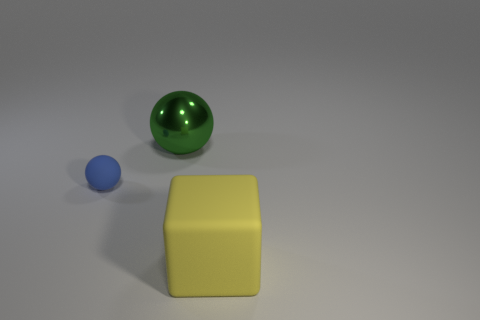Do the yellow object and the big green metallic object have the same shape?
Offer a very short reply. No. What number of other things are the same size as the green shiny thing?
Offer a terse response. 1. Are there fewer yellow matte blocks that are on the right side of the small matte ball than small matte spheres?
Provide a succinct answer. No. How big is the ball that is behind the thing left of the metal thing?
Provide a short and direct response. Large. How many things are either brown spheres or green balls?
Make the answer very short. 1. Are there any blocks that have the same color as the small rubber ball?
Provide a short and direct response. No. Is the number of big rubber cylinders less than the number of blue balls?
Keep it short and to the point. Yes. How many objects are either large balls or big shiny things that are behind the big matte thing?
Keep it short and to the point. 1. Is there a tiny sphere made of the same material as the tiny blue thing?
Your answer should be very brief. No. There is another thing that is the same size as the green shiny thing; what material is it?
Ensure brevity in your answer.  Rubber. 